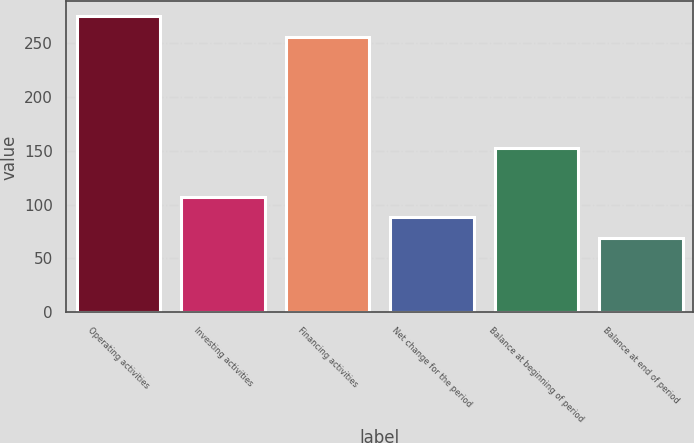Convert chart to OTSL. <chart><loc_0><loc_0><loc_500><loc_500><bar_chart><fcel>Operating activities<fcel>Investing activities<fcel>Financing activities<fcel>Net change for the period<fcel>Balance at beginning of period<fcel>Balance at end of period<nl><fcel>275.1<fcel>107.2<fcel>256<fcel>88.1<fcel>153<fcel>69<nl></chart> 